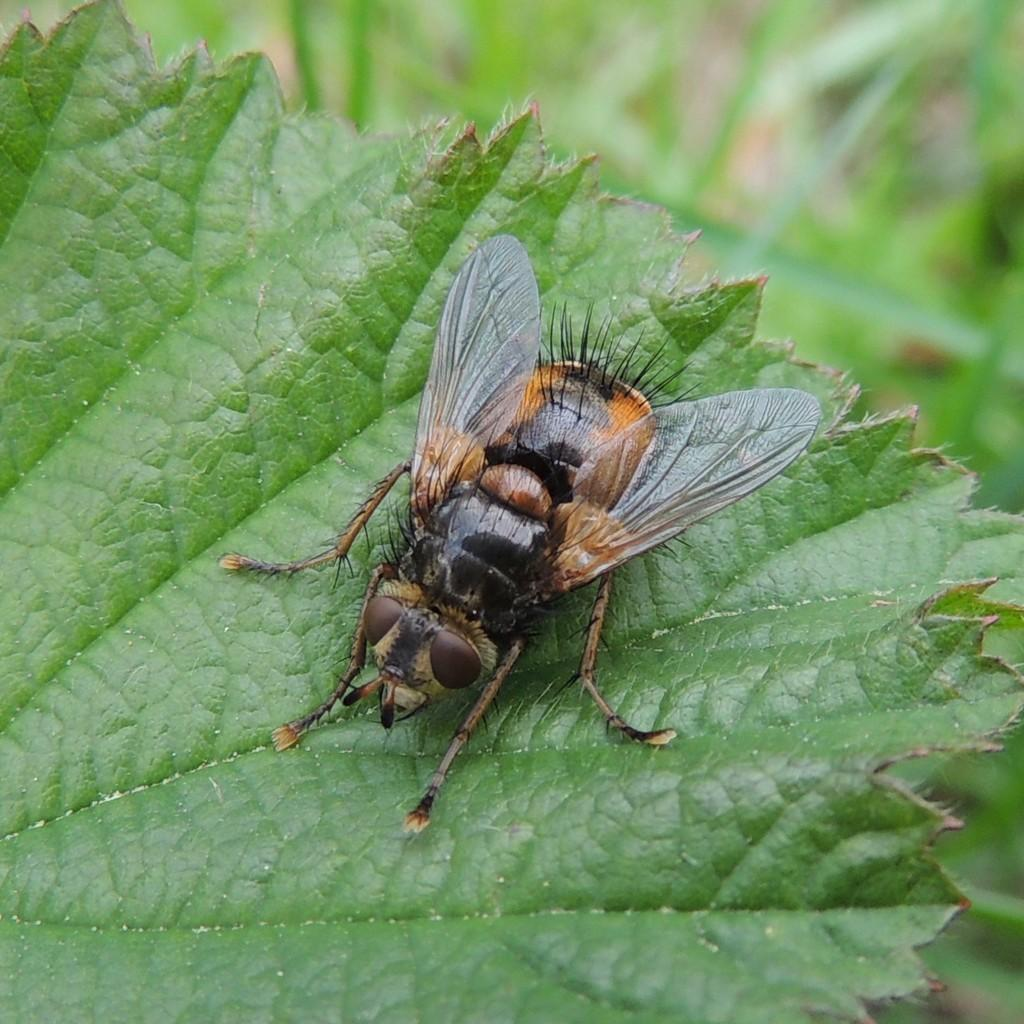What is the main subject of the image? There is an insect on a leaf in the image. Can you describe the background of the image? The background of the image is blurred. What type of patch is sewn onto the trousers in the image? There are no trousers or patches present in the image; it features an insect on a leaf with a blurred background. 